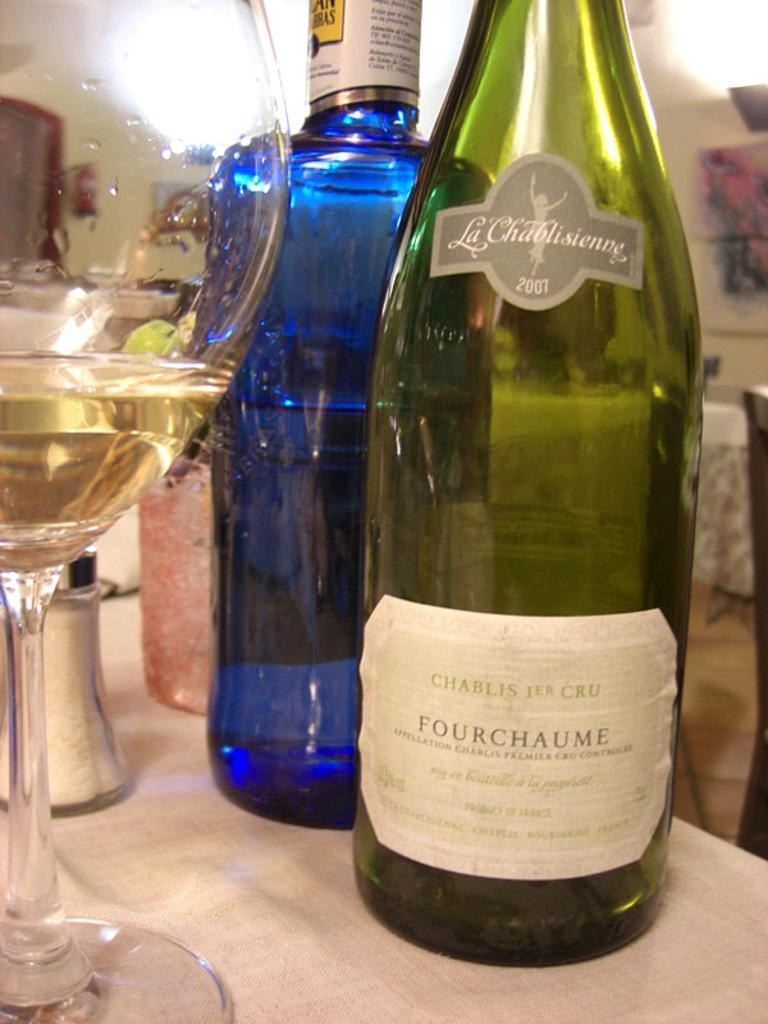What is present on the table in the image? There is a glass and at least two bottles on the table in the image. Can you describe the glass in the image? The glass is visible on the table, but its contents or appearance cannot be determined from the provided facts. How many bottles are present on the table? There are at least two bottles on the table in the image. What type of tooth can be seen in the image? A: There is no tooth present in the image. How many beads are visible on the table in the image? There are no beads visible on the table in the image. 